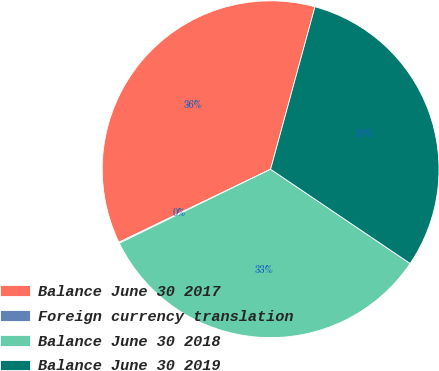Convert chart to OTSL. <chart><loc_0><loc_0><loc_500><loc_500><pie_chart><fcel>Balance June 30 2017<fcel>Foreign currency translation<fcel>Balance June 30 2018<fcel>Balance June 30 2019<nl><fcel>36.38%<fcel>0.1%<fcel>33.3%<fcel>30.21%<nl></chart> 